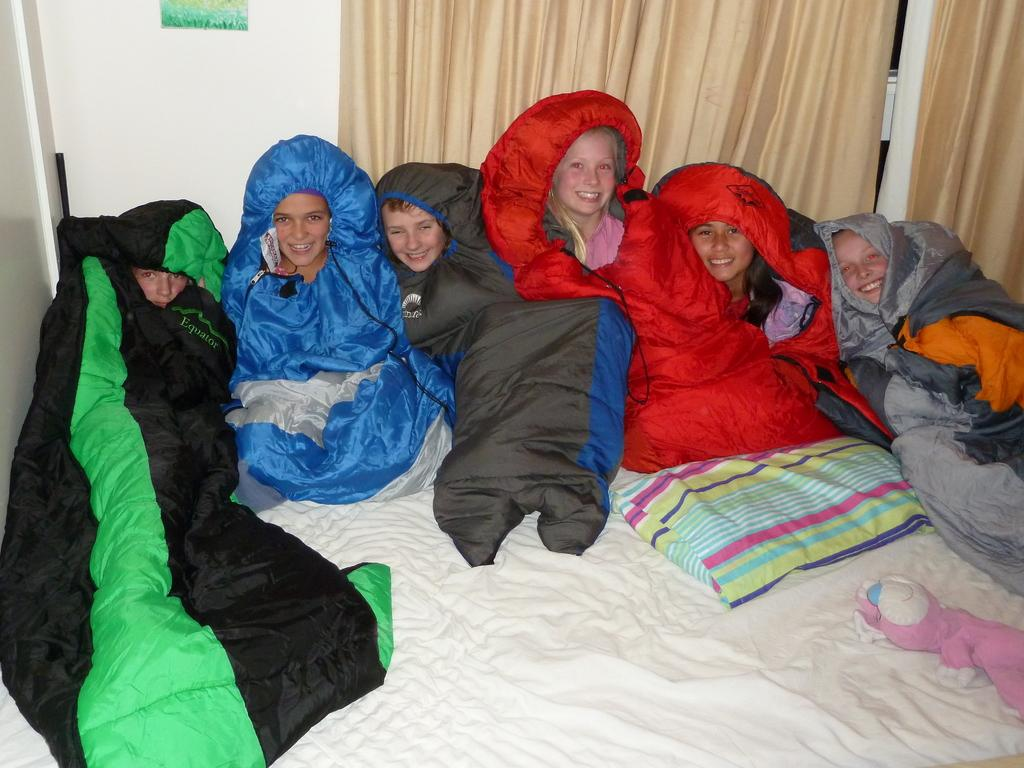What are the people doing in the image? The people are on the bed in the image. What can be seen on the bed besides the people? There is a pillow and a soft toy visible on the bed. What is present in the background of the image? There are curtains in the background of the image. What is on the wall in the image? There is a poster on a wall in the image. What type of steel object can be seen in the image? There is no steel object present in the image. Is there a rabbit visible in the image? No, there is no rabbit present in the image. 